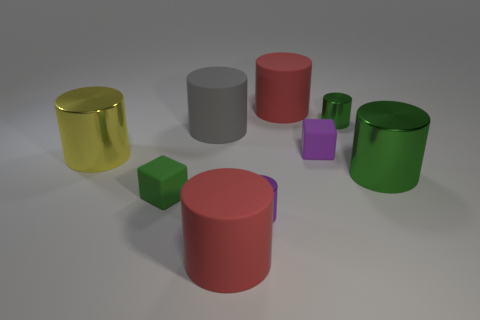How many other things are made of the same material as the purple cylinder? Upon close inspection of the image, it appears that there are three other objects that have a similar matte surface and solidity, suggesting they are made of the same material as the purple cylinder. 